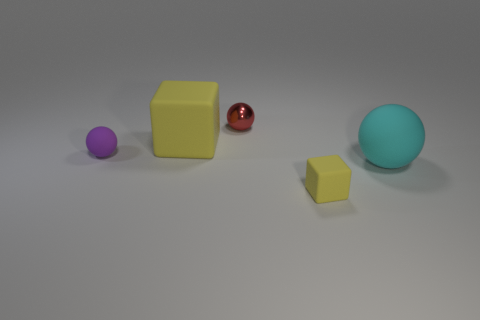What is the shape of the object that is the same color as the small matte cube?
Ensure brevity in your answer.  Cube. Are there any other matte cubes of the same color as the small cube?
Give a very brief answer. Yes. How many small yellow things are on the right side of the cyan matte sphere?
Your answer should be very brief. 0. There is a rubber object that is in front of the ball that is right of the red metallic thing; what is its color?
Ensure brevity in your answer.  Yellow. How many other objects are there of the same material as the purple ball?
Provide a succinct answer. 3. Are there the same number of yellow objects that are behind the purple sphere and red metal objects?
Ensure brevity in your answer.  Yes. What is the material of the small thing that is in front of the tiny sphere on the left side of the tiny sphere behind the purple sphere?
Make the answer very short. Rubber. What is the color of the rubber ball on the right side of the small red ball?
Ensure brevity in your answer.  Cyan. What is the size of the yellow cube in front of the rubber ball on the right side of the purple matte sphere?
Your answer should be compact. Small. Is the number of red spheres to the left of the red metal object the same as the number of small things that are on the left side of the large matte block?
Your answer should be compact. No. 